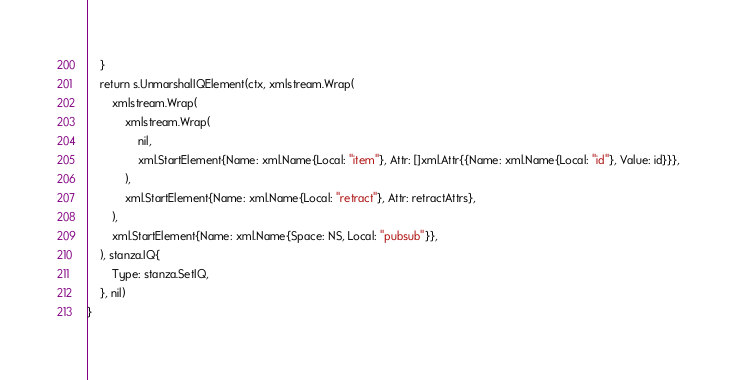<code> <loc_0><loc_0><loc_500><loc_500><_Go_>	}
	return s.UnmarshalIQElement(ctx, xmlstream.Wrap(
		xmlstream.Wrap(
			xmlstream.Wrap(
				nil,
				xml.StartElement{Name: xml.Name{Local: "item"}, Attr: []xml.Attr{{Name: xml.Name{Local: "id"}, Value: id}}},
			),
			xml.StartElement{Name: xml.Name{Local: "retract"}, Attr: retractAttrs},
		),
		xml.StartElement{Name: xml.Name{Space: NS, Local: "pubsub"}},
	), stanza.IQ{
		Type: stanza.SetIQ,
	}, nil)
}
</code> 